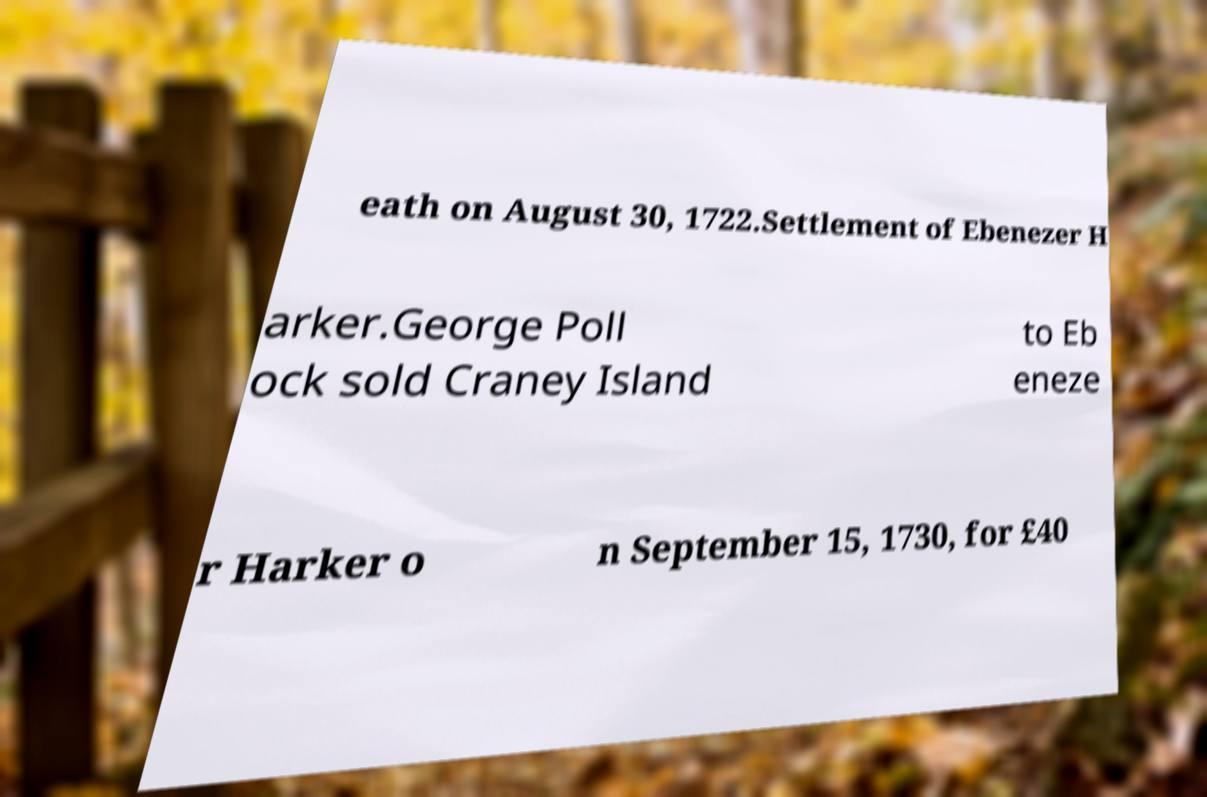There's text embedded in this image that I need extracted. Can you transcribe it verbatim? eath on August 30, 1722.Settlement of Ebenezer H arker.George Poll ock sold Craney Island to Eb eneze r Harker o n September 15, 1730, for £40 